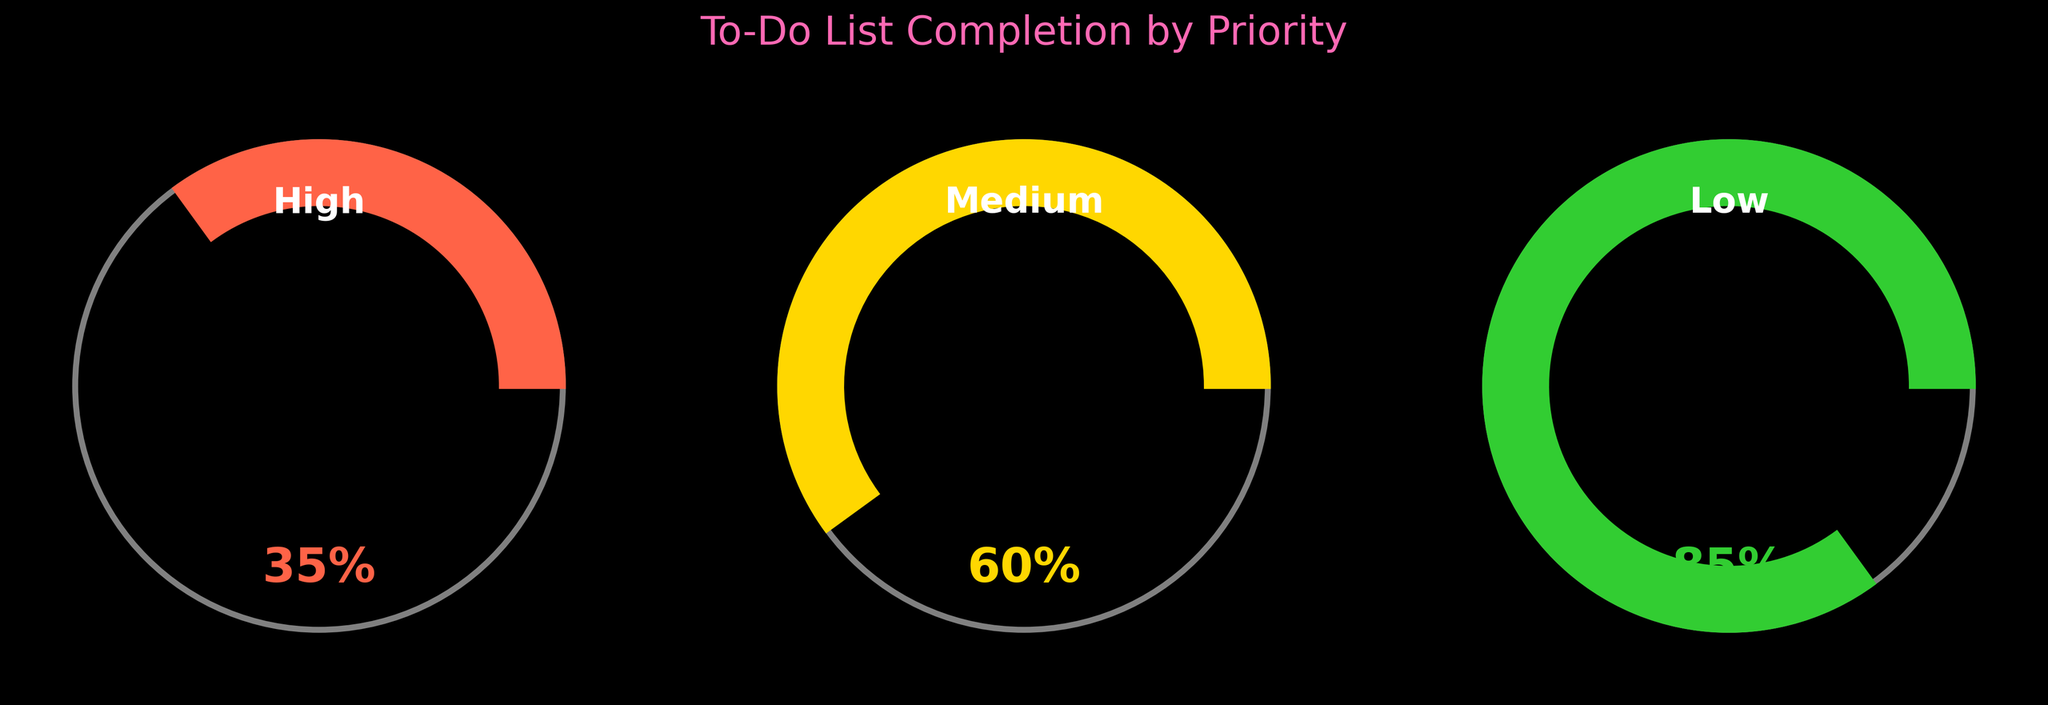What is the completion percentage for high-priority to-do items? The gauge for high-priority to-do items shows a completion percentage value. The number displayed is 35%.
Answer: 35% What are the colors used for each priority level? The High priority gauge is in red, Medium priority gauge is in gold, and Low priority gauge is in green.
Answer: Red, Gold, Green Which priority level has the highest completion percentage? By looking at the gauge values, the Low priority items have the highest completion percentage, which is displayed as 85%.
Answer: Low What is the average completion percentage across all priority levels? Add the completion percentages (35, 60, 85) and divide by the number of priorities (3). Calculation: (35 + 60 + 85) / 3 = 180 / 3 = 60.
Answer: 60% How much greater is the completion percentage of low-priority items compared to high-priority items? Subtract the completion percentage of high-priority items (35%) from the completion percentage of low-priority items (85%). Calculation: 85 - 35 = 50.
Answer: 50% What is the approximate range of completion percentages across the three priority levels? The highest percentage is 85% (Low) and the lowest is 35% (High). Calculation: 85 - 35 = 50.
Answer: 50% Which priority level has the lowest completion percentage and by how much does it differ from the medium-priority level? The High priority level has the lowest completion percentage at 35%. To find the difference with the Medium level (60%), calculate 60 - 35.
Answer: High, 25% By how much does the medium-priority completion percentage exceed the high-priority completion percentage? Subtract the high-priority completion percentage (35%) from the medium-priority completion percentage (60%). Calculation: 60 - 35 = 25.
Answer: 25% What is the title of the figure? The title is displayed at the top of the figure and reads "To-Do List Completion by Priority".
Answer: To-Do List Completion by Priority How does the completion percentage for medium-priority items compare to the average completion percentage? The average completion percentage across all priority levels is 60%. The completion percentage for medium-priority items is also 60%, so they are equal.
Answer: Equal 